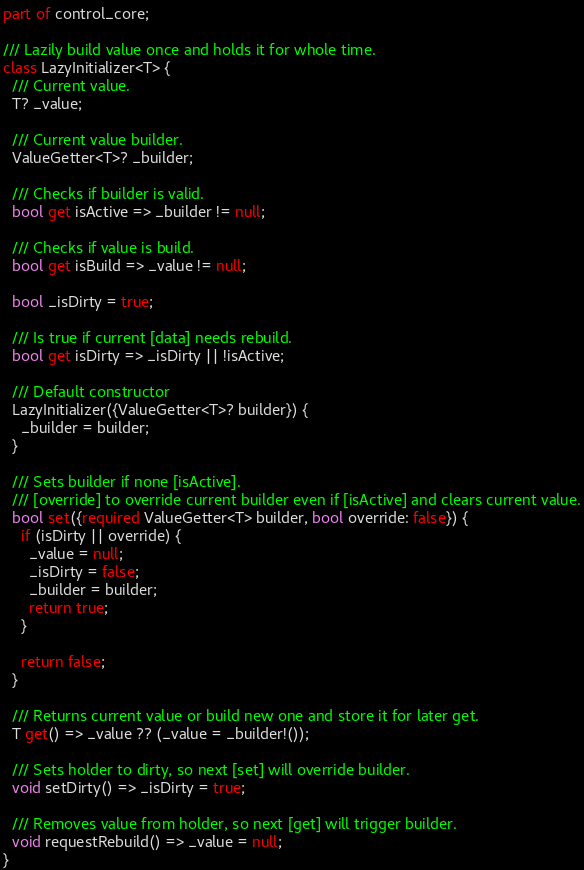Convert code to text. <code><loc_0><loc_0><loc_500><loc_500><_Dart_>part of control_core;

/// Lazily build value once and holds it for whole time.
class LazyInitializer<T> {
  /// Current value.
  T? _value;

  /// Current value builder.
  ValueGetter<T>? _builder;

  /// Checks if builder is valid.
  bool get isActive => _builder != null;

  /// Checks if value is build.
  bool get isBuild => _value != null;

  bool _isDirty = true;

  /// Is true if current [data] needs rebuild.
  bool get isDirty => _isDirty || !isActive;

  /// Default constructor
  LazyInitializer({ValueGetter<T>? builder}) {
    _builder = builder;
  }

  /// Sets builder if none [isActive].
  /// [override] to override current builder even if [isActive] and clears current value.
  bool set({required ValueGetter<T> builder, bool override: false}) {
    if (isDirty || override) {
      _value = null;
      _isDirty = false;
      _builder = builder;
      return true;
    }

    return false;
  }

  /// Returns current value or build new one and store it for later get.
  T get() => _value ?? (_value = _builder!());

  /// Sets holder to dirty, so next [set] will override builder.
  void setDirty() => _isDirty = true;

  /// Removes value from holder, so next [get] will trigger builder.
  void requestRebuild() => _value = null;
}
</code> 